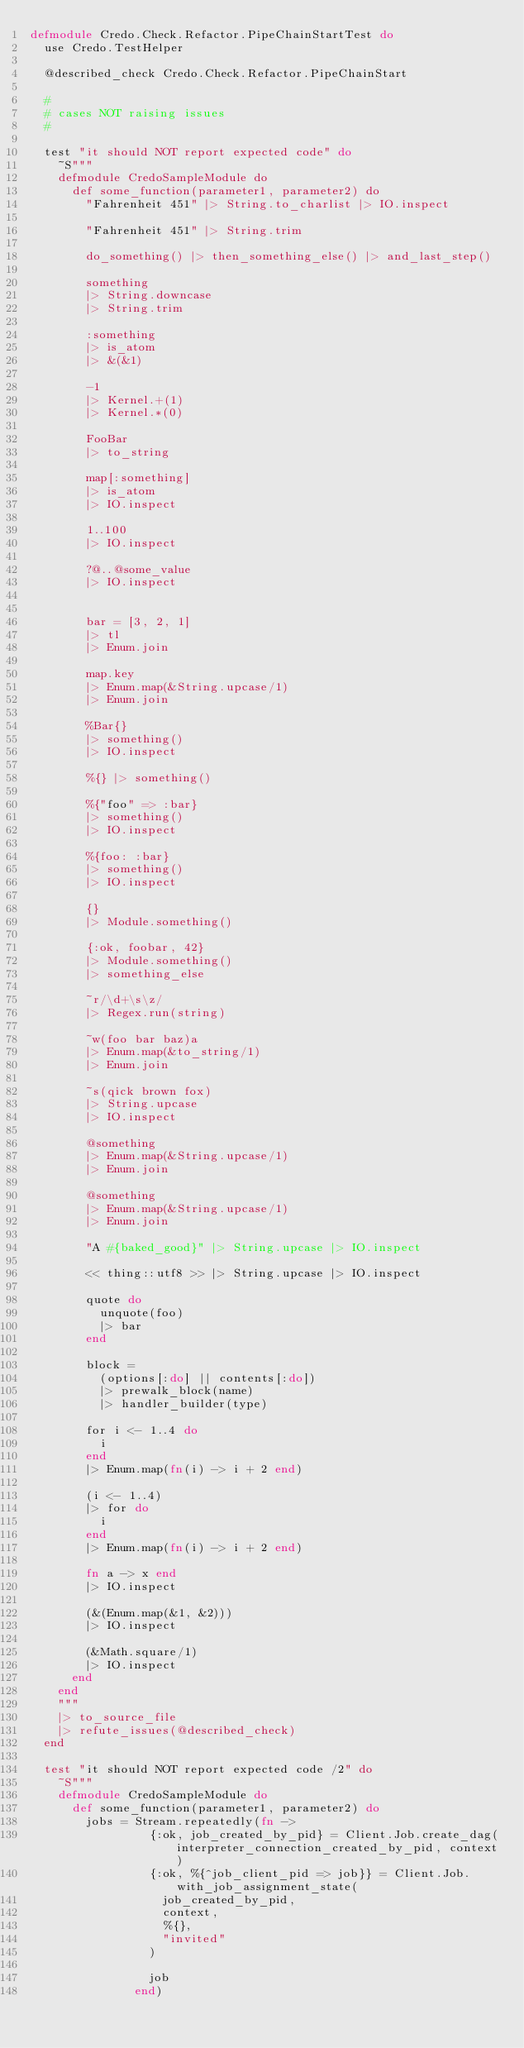<code> <loc_0><loc_0><loc_500><loc_500><_Elixir_>defmodule Credo.Check.Refactor.PipeChainStartTest do
  use Credo.TestHelper

  @described_check Credo.Check.Refactor.PipeChainStart

  #
  # cases NOT raising issues
  #

  test "it should NOT report expected code" do
    ~S"""
    defmodule CredoSampleModule do
      def some_function(parameter1, parameter2) do
        "Fahrenheit 451" |> String.to_charlist |> IO.inspect

        "Fahrenheit 451" |> String.trim

        do_something() |> then_something_else() |> and_last_step()

        something
        |> String.downcase
        |> String.trim

        :something
        |> is_atom
        |> &(&1)

        -1
        |> Kernel.+(1)
        |> Kernel.*(0)

        FooBar
        |> to_string

        map[:something]
        |> is_atom
        |> IO.inspect

        1..100
        |> IO.inspect

        ?@..@some_value
        |> IO.inspect


        bar = [3, 2, 1]
        |> tl
        |> Enum.join

        map.key
        |> Enum.map(&String.upcase/1)
        |> Enum.join

        %Bar{}
        |> something()
        |> IO.inspect

        %{} |> something()

        %{"foo" => :bar}
        |> something()
        |> IO.inspect

        %{foo: :bar}
        |> something()
        |> IO.inspect

        {}
        |> Module.something()

        {:ok, foobar, 42}
        |> Module.something()
        |> something_else

        ~r/\d+\s\z/
        |> Regex.run(string)

        ~w(foo bar baz)a
        |> Enum.map(&to_string/1)
        |> Enum.join

        ~s(qick brown fox)
        |> String.upcase
        |> IO.inspect

        @something
        |> Enum.map(&String.upcase/1)
        |> Enum.join

        @something
        |> Enum.map(&String.upcase/1)
        |> Enum.join

        "A #{baked_good}" |> String.upcase |> IO.inspect

        << thing::utf8 >> |> String.upcase |> IO.inspect

        quote do
          unquote(foo)
          |> bar
        end

        block =
          (options[:do] || contents[:do])
          |> prewalk_block(name)
          |> handler_builder(type)

        for i <- 1..4 do
          i
        end
        |> Enum.map(fn(i) -> i + 2 end)

        (i <- 1..4)
        |> for do
          i
        end
        |> Enum.map(fn(i) -> i + 2 end)

        fn a -> x end
        |> IO.inspect

        (&(Enum.map(&1, &2)))
        |> IO.inspect

        (&Math.square/1)
        |> IO.inspect
      end
    end
    """
    |> to_source_file
    |> refute_issues(@described_check)
  end

  test "it should NOT report expected code /2" do
    ~S"""
    defmodule CredoSampleModule do
      def some_function(parameter1, parameter2) do
        jobs = Stream.repeatedly(fn ->
                 {:ok, job_created_by_pid} = Client.Job.create_dag(interpreter_connection_created_by_pid, context)
                 {:ok, %{^job_client_pid => job}} = Client.Job.with_job_assignment_state(
                   job_created_by_pid,
                   context,
                   %{},
                   "invited"
                 )

                 job
               end)</code> 